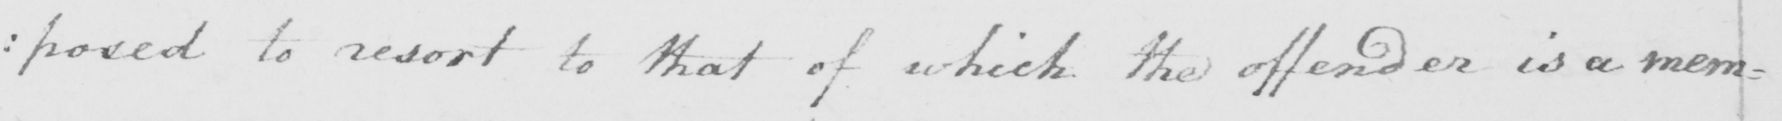Transcribe the text shown in this historical manuscript line. :posed to resort to that of which the offender is a mem= 